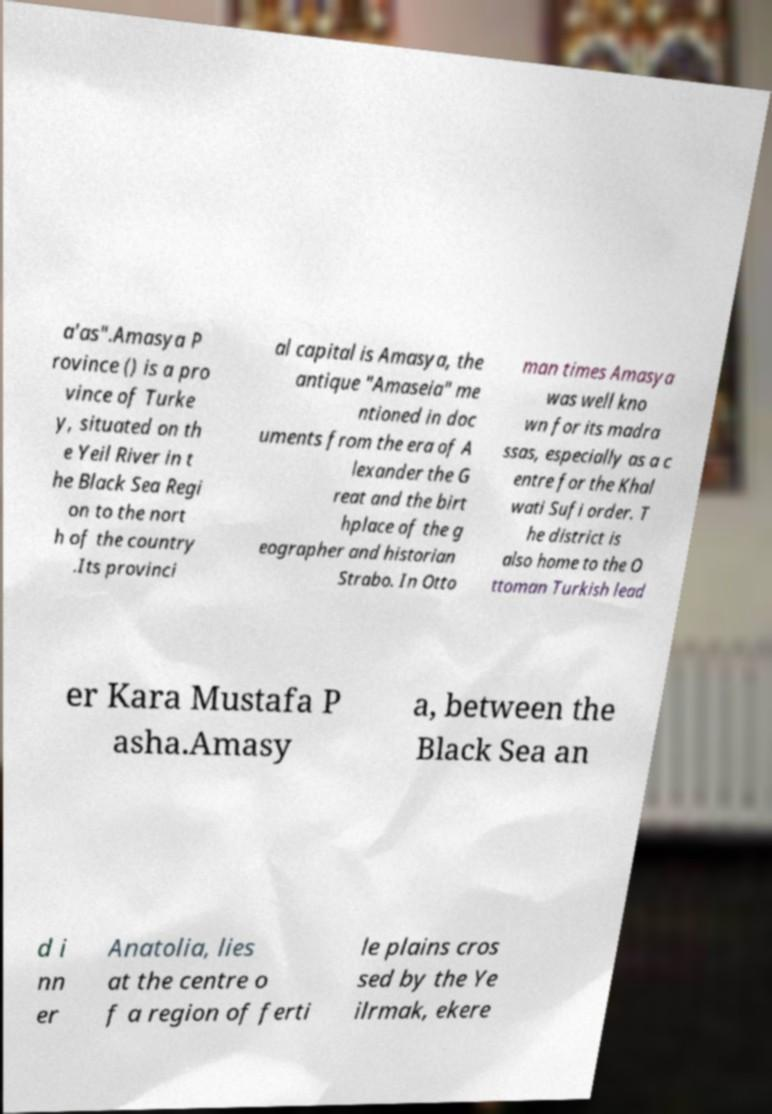For documentation purposes, I need the text within this image transcribed. Could you provide that? a'as".Amasya P rovince () is a pro vince of Turke y, situated on th e Yeil River in t he Black Sea Regi on to the nort h of the country .Its provinci al capital is Amasya, the antique "Amaseia" me ntioned in doc uments from the era of A lexander the G reat and the birt hplace of the g eographer and historian Strabo. In Otto man times Amasya was well kno wn for its madra ssas, especially as a c entre for the Khal wati Sufi order. T he district is also home to the O ttoman Turkish lead er Kara Mustafa P asha.Amasy a, between the Black Sea an d i nn er Anatolia, lies at the centre o f a region of ferti le plains cros sed by the Ye ilrmak, ekere 